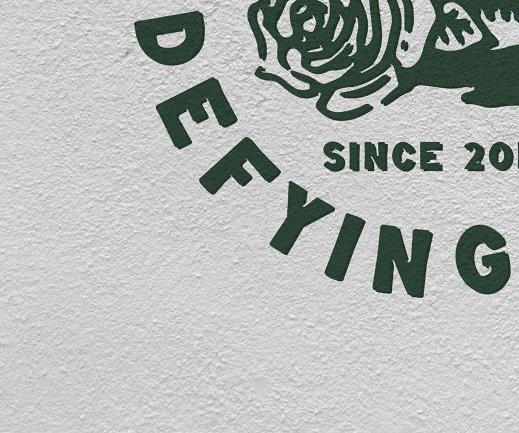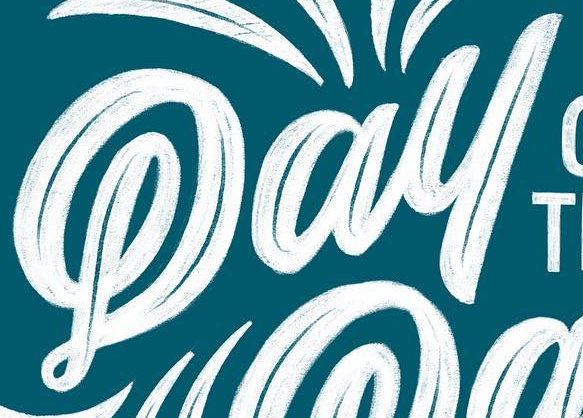What words are shown in these images in order, separated by a semicolon? DEFYING; Pay 